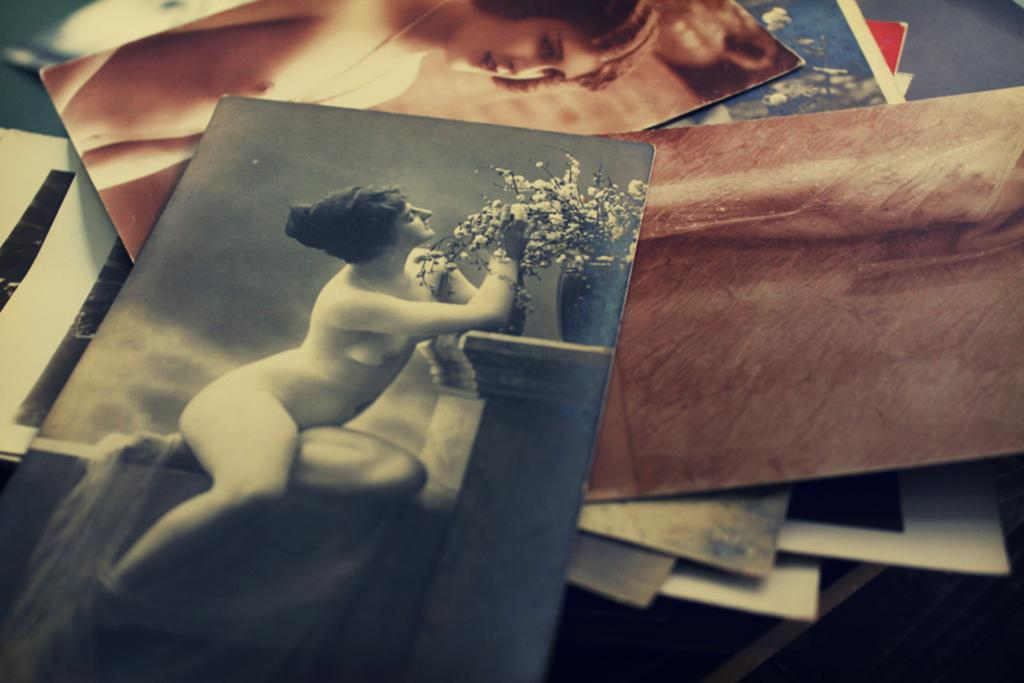What is present in the image? There are photographs in the image. Where are the photographs located? The photographs are placed on a table. What type of van can be seen in the image? There is no van present in the image; it only contains photographs placed on a table. What type of sponge is used to clean the photographs in the image? There is no sponge or cleaning activity depicted in the image; it only shows photographs placed on a table. 